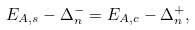<formula> <loc_0><loc_0><loc_500><loc_500>E _ { A , s } - \Delta _ { n } ^ { - } = E _ { A , c } - \Delta _ { n } ^ { + } ,</formula> 